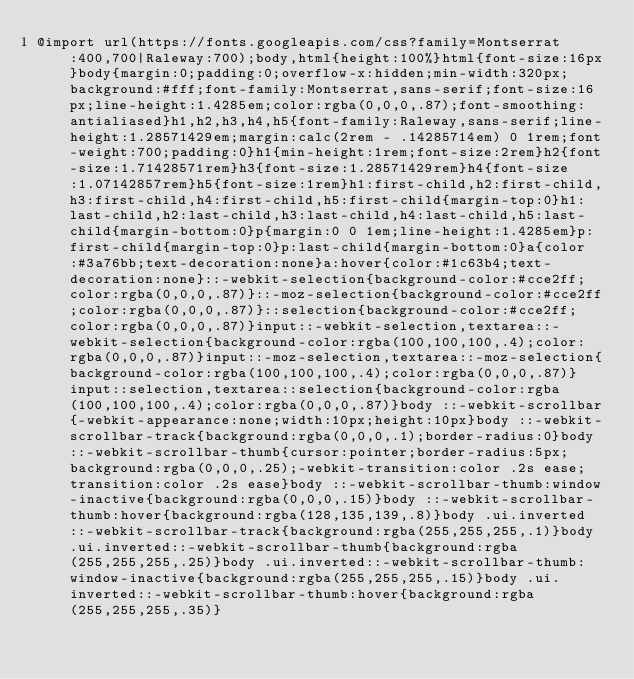Convert code to text. <code><loc_0><loc_0><loc_500><loc_500><_CSS_>@import url(https://fonts.googleapis.com/css?family=Montserrat:400,700|Raleway:700);body,html{height:100%}html{font-size:16px}body{margin:0;padding:0;overflow-x:hidden;min-width:320px;background:#fff;font-family:Montserrat,sans-serif;font-size:16px;line-height:1.4285em;color:rgba(0,0,0,.87);font-smoothing:antialiased}h1,h2,h3,h4,h5{font-family:Raleway,sans-serif;line-height:1.28571429em;margin:calc(2rem - .14285714em) 0 1rem;font-weight:700;padding:0}h1{min-height:1rem;font-size:2rem}h2{font-size:1.71428571rem}h3{font-size:1.28571429rem}h4{font-size:1.07142857rem}h5{font-size:1rem}h1:first-child,h2:first-child,h3:first-child,h4:first-child,h5:first-child{margin-top:0}h1:last-child,h2:last-child,h3:last-child,h4:last-child,h5:last-child{margin-bottom:0}p{margin:0 0 1em;line-height:1.4285em}p:first-child{margin-top:0}p:last-child{margin-bottom:0}a{color:#3a76bb;text-decoration:none}a:hover{color:#1c63b4;text-decoration:none}::-webkit-selection{background-color:#cce2ff;color:rgba(0,0,0,.87)}::-moz-selection{background-color:#cce2ff;color:rgba(0,0,0,.87)}::selection{background-color:#cce2ff;color:rgba(0,0,0,.87)}input::-webkit-selection,textarea::-webkit-selection{background-color:rgba(100,100,100,.4);color:rgba(0,0,0,.87)}input::-moz-selection,textarea::-moz-selection{background-color:rgba(100,100,100,.4);color:rgba(0,0,0,.87)}input::selection,textarea::selection{background-color:rgba(100,100,100,.4);color:rgba(0,0,0,.87)}body ::-webkit-scrollbar{-webkit-appearance:none;width:10px;height:10px}body ::-webkit-scrollbar-track{background:rgba(0,0,0,.1);border-radius:0}body ::-webkit-scrollbar-thumb{cursor:pointer;border-radius:5px;background:rgba(0,0,0,.25);-webkit-transition:color .2s ease;transition:color .2s ease}body ::-webkit-scrollbar-thumb:window-inactive{background:rgba(0,0,0,.15)}body ::-webkit-scrollbar-thumb:hover{background:rgba(128,135,139,.8)}body .ui.inverted::-webkit-scrollbar-track{background:rgba(255,255,255,.1)}body .ui.inverted::-webkit-scrollbar-thumb{background:rgba(255,255,255,.25)}body .ui.inverted::-webkit-scrollbar-thumb:window-inactive{background:rgba(255,255,255,.15)}body .ui.inverted::-webkit-scrollbar-thumb:hover{background:rgba(255,255,255,.35)}</code> 